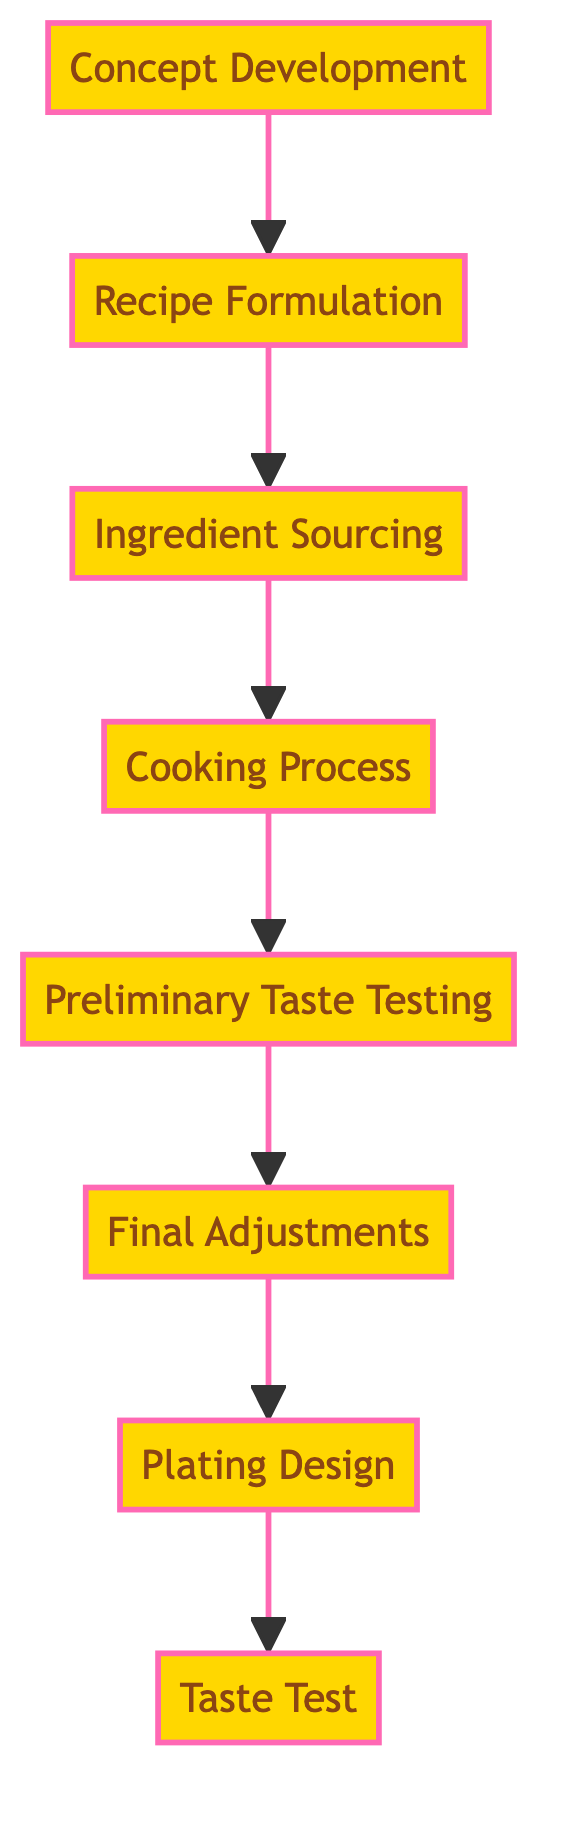What is the first step in the culinary experimentation process? The first step in the flow chart starts with 'Concept Development,' which is indicated as the bottom-most element in the flow.
Answer: Concept Development How many total steps are there in the culinary experimentation process? To find the total steps, count each distinct node in the flow chart: Concept Development, Recipe Formulation, Ingredient Sourcing, Cooking Process, Preliminary Taste Testing, Final Adjustments, Plating Design, and Taste Test. This gives us a total of 8 steps.
Answer: 8 What comes immediately after the Cooking Process? In the flow chart, the node that directly follows 'Cooking Process' is 'Preliminary Taste Testing,' as indicated by the upward arrow connecting these two elements.
Answer: Preliminary Taste Testing What is the last step of the culinary experimentation process? The last step in the flow chart is indicated as 'Taste Test,' which is the highest node in the diagram, showing it's the final stage after all prior steps have been completed.
Answer: Taste Test Which two steps are closely related before final presentation? The diagram shows that 'Final Adjustments' comes directly before 'Plating Design,' indicating a close relationship in this part of the process.
Answer: Final Adjustments and Plating Design Which step focuses on aesthetic arrangement? The step that specifically addresses aesthetic arrangement is 'Plating Design,' as it is dedicated to arranging the dish in an appealing way.
Answer: Plating Design If no adjustments are required, which step follows directly after preliminary taste testing? If no adjustments are necessary after 'Preliminary Taste Testing,' the next step would be 'Final Adjustments.' However, if we assume no changes, it can imply the process moves to 'Plating Design.' Starting from the pathway, both can be expected based on the usual flow.
Answer: Plating Design What is the purpose of Ingredient Sourcing in the process? The purpose of 'Ingredient Sourcing' is to select the finest and freshest ingredients for the dish, which is essential before any cooking can occur.
Answer: Selecting ingredients 